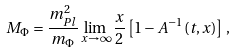Convert formula to latex. <formula><loc_0><loc_0><loc_500><loc_500>M _ { \Phi } = \frac { m ^ { 2 } _ { P l } } { m _ { \Phi } } \lim _ { x \rightarrow \infty } \frac { x } { 2 } \left [ 1 - A ^ { - 1 } ( t , x ) \right ] \, ,</formula> 